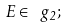Convert formula to latex. <formula><loc_0><loc_0><loc_500><loc_500>E \in \ g _ { 2 } ;</formula> 